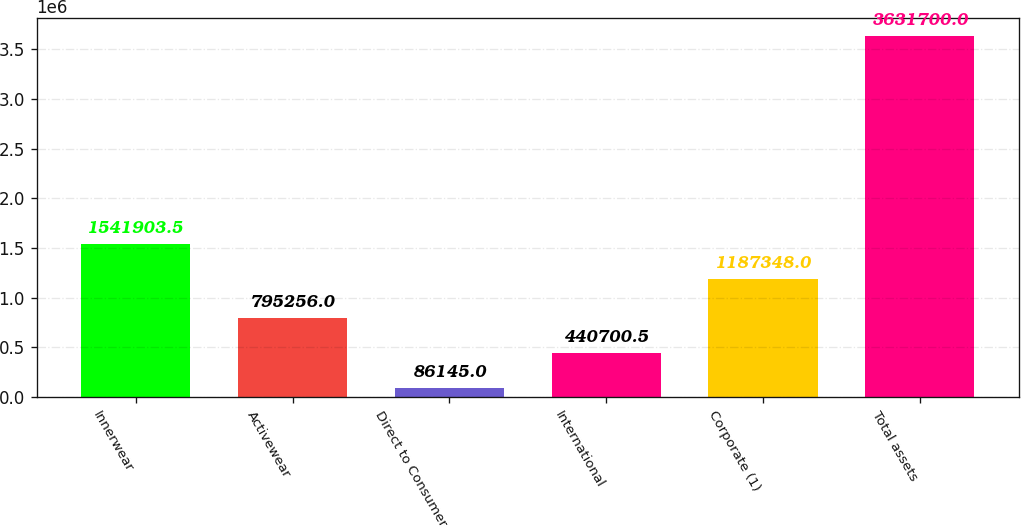Convert chart to OTSL. <chart><loc_0><loc_0><loc_500><loc_500><bar_chart><fcel>Innerwear<fcel>Activewear<fcel>Direct to Consumer<fcel>International<fcel>Corporate (1)<fcel>Total assets<nl><fcel>1.5419e+06<fcel>795256<fcel>86145<fcel>440700<fcel>1.18735e+06<fcel>3.6317e+06<nl></chart> 